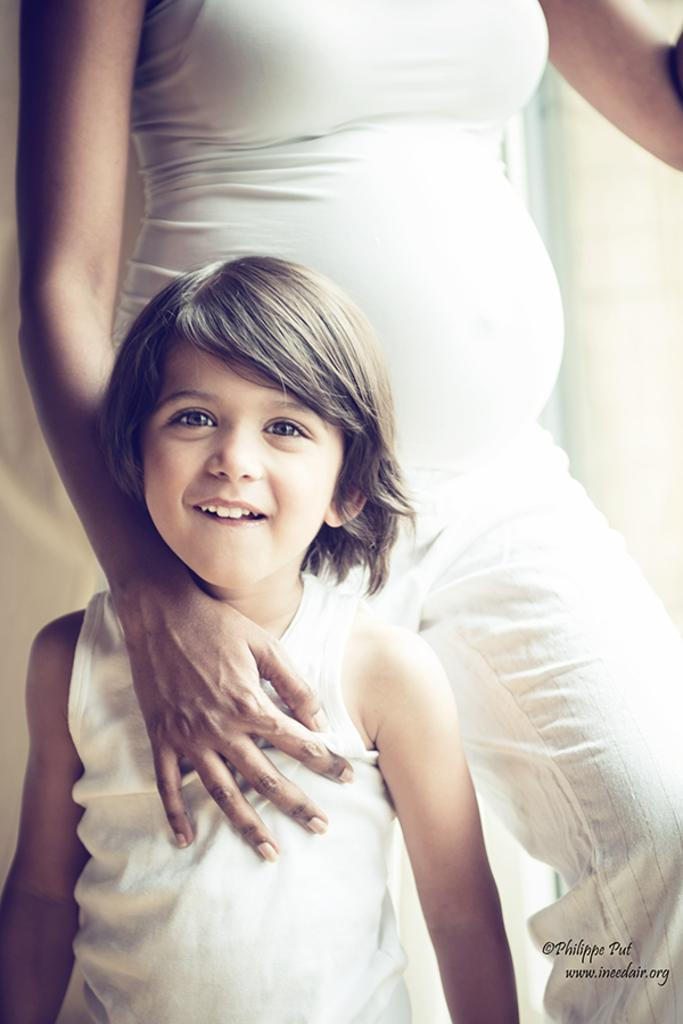Who is the main subject in the image? There is a girl in the center of the image. Can you describe the background of the image? There is a person in the background of the image. How many chains are visible in the image? There are no chains visible in the image. 